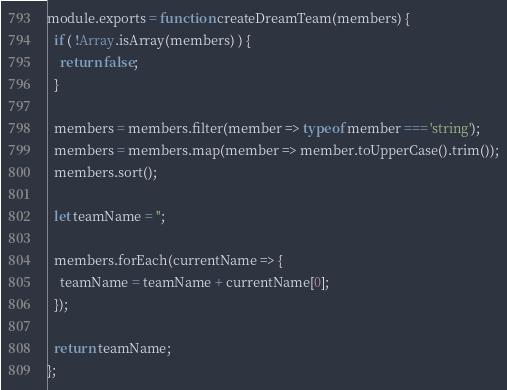<code> <loc_0><loc_0><loc_500><loc_500><_JavaScript_>module.exports = function createDreamTeam(members) {
  if ( !Array.isArray(members) ) {
    return false;
  }

  members = members.filter(member => typeof member === 'string');
  members = members.map(member => member.toUpperCase().trim());
  members.sort();
  
  let teamName = '';

  members.forEach(currentName => {
    teamName = teamName + currentName[0];
  });
  
  return teamName;
};
</code> 